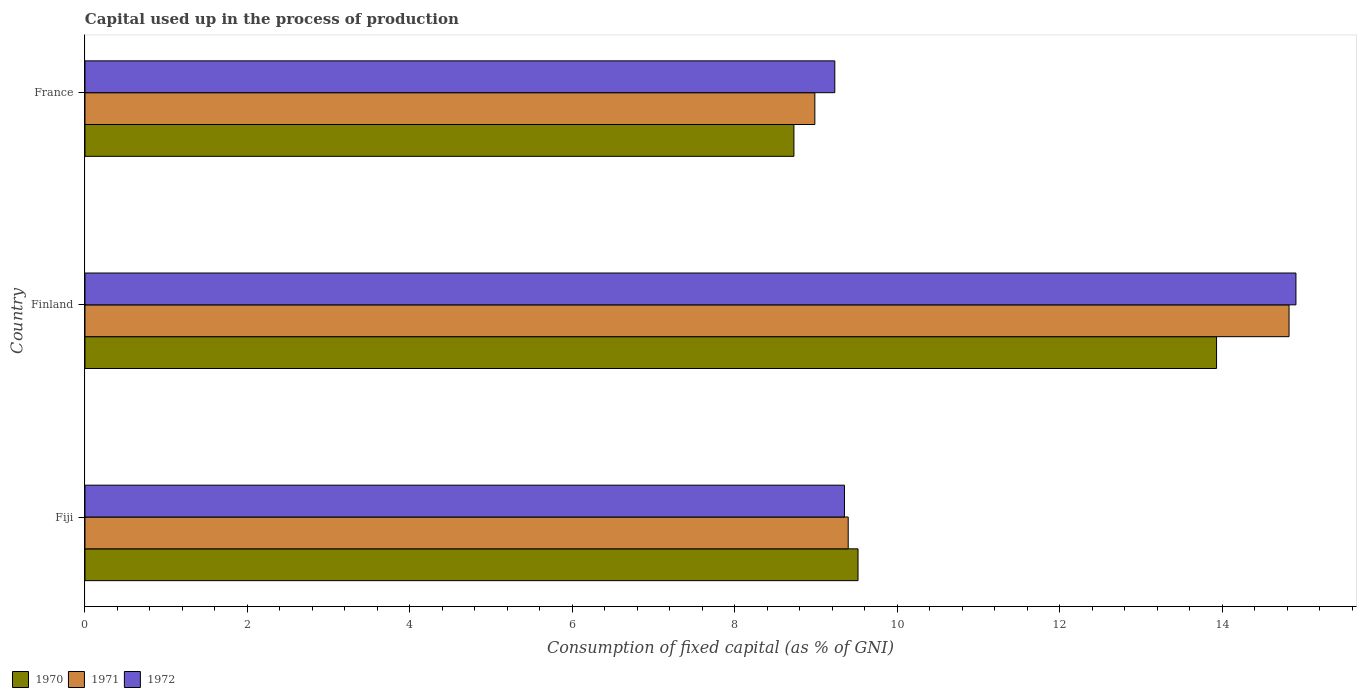How many different coloured bars are there?
Your answer should be compact. 3. How many groups of bars are there?
Provide a succinct answer. 3. Are the number of bars per tick equal to the number of legend labels?
Keep it short and to the point. Yes. How many bars are there on the 3rd tick from the top?
Make the answer very short. 3. How many bars are there on the 3rd tick from the bottom?
Ensure brevity in your answer.  3. What is the label of the 3rd group of bars from the top?
Offer a terse response. Fiji. In how many cases, is the number of bars for a given country not equal to the number of legend labels?
Your response must be concise. 0. What is the capital used up in the process of production in 1972 in Fiji?
Provide a succinct answer. 9.35. Across all countries, what is the maximum capital used up in the process of production in 1970?
Your answer should be compact. 13.93. Across all countries, what is the minimum capital used up in the process of production in 1971?
Your answer should be very brief. 8.98. In which country was the capital used up in the process of production in 1972 maximum?
Your response must be concise. Finland. What is the total capital used up in the process of production in 1970 in the graph?
Provide a succinct answer. 32.17. What is the difference between the capital used up in the process of production in 1972 in Fiji and that in France?
Your answer should be very brief. 0.12. What is the difference between the capital used up in the process of production in 1971 in Fiji and the capital used up in the process of production in 1970 in Finland?
Provide a short and direct response. -4.53. What is the average capital used up in the process of production in 1971 per country?
Provide a succinct answer. 11.07. What is the difference between the capital used up in the process of production in 1970 and capital used up in the process of production in 1972 in Fiji?
Give a very brief answer. 0.17. In how many countries, is the capital used up in the process of production in 1972 greater than 0.4 %?
Give a very brief answer. 3. What is the ratio of the capital used up in the process of production in 1970 in Finland to that in France?
Give a very brief answer. 1.6. Is the difference between the capital used up in the process of production in 1970 in Fiji and Finland greater than the difference between the capital used up in the process of production in 1972 in Fiji and Finland?
Ensure brevity in your answer.  Yes. What is the difference between the highest and the second highest capital used up in the process of production in 1970?
Your response must be concise. 4.41. What is the difference between the highest and the lowest capital used up in the process of production in 1972?
Your response must be concise. 5.68. Is the sum of the capital used up in the process of production in 1972 in Finland and France greater than the maximum capital used up in the process of production in 1971 across all countries?
Provide a succinct answer. Yes. What does the 2nd bar from the top in Finland represents?
Make the answer very short. 1971. What does the 3rd bar from the bottom in Finland represents?
Offer a terse response. 1972. How many bars are there?
Your response must be concise. 9. Does the graph contain any zero values?
Give a very brief answer. No. Does the graph contain grids?
Offer a terse response. No. Where does the legend appear in the graph?
Your response must be concise. Bottom left. What is the title of the graph?
Provide a succinct answer. Capital used up in the process of production. What is the label or title of the X-axis?
Give a very brief answer. Consumption of fixed capital (as % of GNI). What is the Consumption of fixed capital (as % of GNI) in 1970 in Fiji?
Your answer should be very brief. 9.52. What is the Consumption of fixed capital (as % of GNI) of 1971 in Fiji?
Provide a succinct answer. 9.39. What is the Consumption of fixed capital (as % of GNI) of 1972 in Fiji?
Provide a succinct answer. 9.35. What is the Consumption of fixed capital (as % of GNI) of 1970 in Finland?
Your answer should be very brief. 13.93. What is the Consumption of fixed capital (as % of GNI) in 1971 in Finland?
Make the answer very short. 14.82. What is the Consumption of fixed capital (as % of GNI) of 1972 in Finland?
Offer a very short reply. 14.9. What is the Consumption of fixed capital (as % of GNI) in 1970 in France?
Your answer should be very brief. 8.73. What is the Consumption of fixed capital (as % of GNI) of 1971 in France?
Your response must be concise. 8.98. What is the Consumption of fixed capital (as % of GNI) in 1972 in France?
Your answer should be very brief. 9.23. Across all countries, what is the maximum Consumption of fixed capital (as % of GNI) in 1970?
Give a very brief answer. 13.93. Across all countries, what is the maximum Consumption of fixed capital (as % of GNI) in 1971?
Ensure brevity in your answer.  14.82. Across all countries, what is the maximum Consumption of fixed capital (as % of GNI) in 1972?
Give a very brief answer. 14.9. Across all countries, what is the minimum Consumption of fixed capital (as % of GNI) in 1970?
Provide a short and direct response. 8.73. Across all countries, what is the minimum Consumption of fixed capital (as % of GNI) of 1971?
Offer a terse response. 8.98. Across all countries, what is the minimum Consumption of fixed capital (as % of GNI) in 1972?
Your answer should be compact. 9.23. What is the total Consumption of fixed capital (as % of GNI) of 1970 in the graph?
Ensure brevity in your answer.  32.17. What is the total Consumption of fixed capital (as % of GNI) in 1971 in the graph?
Your answer should be very brief. 33.2. What is the total Consumption of fixed capital (as % of GNI) of 1972 in the graph?
Offer a terse response. 33.48. What is the difference between the Consumption of fixed capital (as % of GNI) in 1970 in Fiji and that in Finland?
Keep it short and to the point. -4.41. What is the difference between the Consumption of fixed capital (as % of GNI) in 1971 in Fiji and that in Finland?
Make the answer very short. -5.43. What is the difference between the Consumption of fixed capital (as % of GNI) of 1972 in Fiji and that in Finland?
Your answer should be very brief. -5.56. What is the difference between the Consumption of fixed capital (as % of GNI) of 1970 in Fiji and that in France?
Keep it short and to the point. 0.79. What is the difference between the Consumption of fixed capital (as % of GNI) of 1971 in Fiji and that in France?
Give a very brief answer. 0.41. What is the difference between the Consumption of fixed capital (as % of GNI) of 1972 in Fiji and that in France?
Your answer should be compact. 0.12. What is the difference between the Consumption of fixed capital (as % of GNI) of 1970 in Finland and that in France?
Your answer should be very brief. 5.2. What is the difference between the Consumption of fixed capital (as % of GNI) of 1971 in Finland and that in France?
Provide a short and direct response. 5.84. What is the difference between the Consumption of fixed capital (as % of GNI) in 1972 in Finland and that in France?
Give a very brief answer. 5.68. What is the difference between the Consumption of fixed capital (as % of GNI) of 1970 in Fiji and the Consumption of fixed capital (as % of GNI) of 1971 in Finland?
Make the answer very short. -5.3. What is the difference between the Consumption of fixed capital (as % of GNI) in 1970 in Fiji and the Consumption of fixed capital (as % of GNI) in 1972 in Finland?
Keep it short and to the point. -5.39. What is the difference between the Consumption of fixed capital (as % of GNI) of 1971 in Fiji and the Consumption of fixed capital (as % of GNI) of 1972 in Finland?
Offer a very short reply. -5.51. What is the difference between the Consumption of fixed capital (as % of GNI) of 1970 in Fiji and the Consumption of fixed capital (as % of GNI) of 1971 in France?
Provide a succinct answer. 0.53. What is the difference between the Consumption of fixed capital (as % of GNI) of 1970 in Fiji and the Consumption of fixed capital (as % of GNI) of 1972 in France?
Your answer should be very brief. 0.29. What is the difference between the Consumption of fixed capital (as % of GNI) of 1971 in Fiji and the Consumption of fixed capital (as % of GNI) of 1972 in France?
Ensure brevity in your answer.  0.17. What is the difference between the Consumption of fixed capital (as % of GNI) in 1970 in Finland and the Consumption of fixed capital (as % of GNI) in 1971 in France?
Provide a short and direct response. 4.94. What is the difference between the Consumption of fixed capital (as % of GNI) of 1970 in Finland and the Consumption of fixed capital (as % of GNI) of 1972 in France?
Your response must be concise. 4.7. What is the difference between the Consumption of fixed capital (as % of GNI) in 1971 in Finland and the Consumption of fixed capital (as % of GNI) in 1972 in France?
Offer a very short reply. 5.59. What is the average Consumption of fixed capital (as % of GNI) in 1970 per country?
Your response must be concise. 10.72. What is the average Consumption of fixed capital (as % of GNI) in 1971 per country?
Offer a very short reply. 11.07. What is the average Consumption of fixed capital (as % of GNI) in 1972 per country?
Keep it short and to the point. 11.16. What is the difference between the Consumption of fixed capital (as % of GNI) of 1970 and Consumption of fixed capital (as % of GNI) of 1971 in Fiji?
Your answer should be very brief. 0.12. What is the difference between the Consumption of fixed capital (as % of GNI) of 1970 and Consumption of fixed capital (as % of GNI) of 1972 in Fiji?
Your answer should be compact. 0.17. What is the difference between the Consumption of fixed capital (as % of GNI) of 1971 and Consumption of fixed capital (as % of GNI) of 1972 in Fiji?
Ensure brevity in your answer.  0.05. What is the difference between the Consumption of fixed capital (as % of GNI) in 1970 and Consumption of fixed capital (as % of GNI) in 1971 in Finland?
Your answer should be compact. -0.89. What is the difference between the Consumption of fixed capital (as % of GNI) in 1970 and Consumption of fixed capital (as % of GNI) in 1972 in Finland?
Give a very brief answer. -0.98. What is the difference between the Consumption of fixed capital (as % of GNI) of 1971 and Consumption of fixed capital (as % of GNI) of 1972 in Finland?
Provide a short and direct response. -0.08. What is the difference between the Consumption of fixed capital (as % of GNI) of 1970 and Consumption of fixed capital (as % of GNI) of 1971 in France?
Your answer should be compact. -0.26. What is the difference between the Consumption of fixed capital (as % of GNI) in 1970 and Consumption of fixed capital (as % of GNI) in 1972 in France?
Keep it short and to the point. -0.5. What is the difference between the Consumption of fixed capital (as % of GNI) in 1971 and Consumption of fixed capital (as % of GNI) in 1972 in France?
Ensure brevity in your answer.  -0.25. What is the ratio of the Consumption of fixed capital (as % of GNI) of 1970 in Fiji to that in Finland?
Your answer should be compact. 0.68. What is the ratio of the Consumption of fixed capital (as % of GNI) in 1971 in Fiji to that in Finland?
Make the answer very short. 0.63. What is the ratio of the Consumption of fixed capital (as % of GNI) in 1972 in Fiji to that in Finland?
Provide a short and direct response. 0.63. What is the ratio of the Consumption of fixed capital (as % of GNI) in 1970 in Fiji to that in France?
Offer a very short reply. 1.09. What is the ratio of the Consumption of fixed capital (as % of GNI) in 1971 in Fiji to that in France?
Provide a short and direct response. 1.05. What is the ratio of the Consumption of fixed capital (as % of GNI) of 1972 in Fiji to that in France?
Keep it short and to the point. 1.01. What is the ratio of the Consumption of fixed capital (as % of GNI) of 1970 in Finland to that in France?
Offer a very short reply. 1.6. What is the ratio of the Consumption of fixed capital (as % of GNI) of 1971 in Finland to that in France?
Your response must be concise. 1.65. What is the ratio of the Consumption of fixed capital (as % of GNI) in 1972 in Finland to that in France?
Your answer should be very brief. 1.61. What is the difference between the highest and the second highest Consumption of fixed capital (as % of GNI) of 1970?
Provide a succinct answer. 4.41. What is the difference between the highest and the second highest Consumption of fixed capital (as % of GNI) of 1971?
Offer a terse response. 5.43. What is the difference between the highest and the second highest Consumption of fixed capital (as % of GNI) in 1972?
Give a very brief answer. 5.56. What is the difference between the highest and the lowest Consumption of fixed capital (as % of GNI) in 1970?
Offer a terse response. 5.2. What is the difference between the highest and the lowest Consumption of fixed capital (as % of GNI) in 1971?
Your answer should be very brief. 5.84. What is the difference between the highest and the lowest Consumption of fixed capital (as % of GNI) in 1972?
Provide a short and direct response. 5.68. 